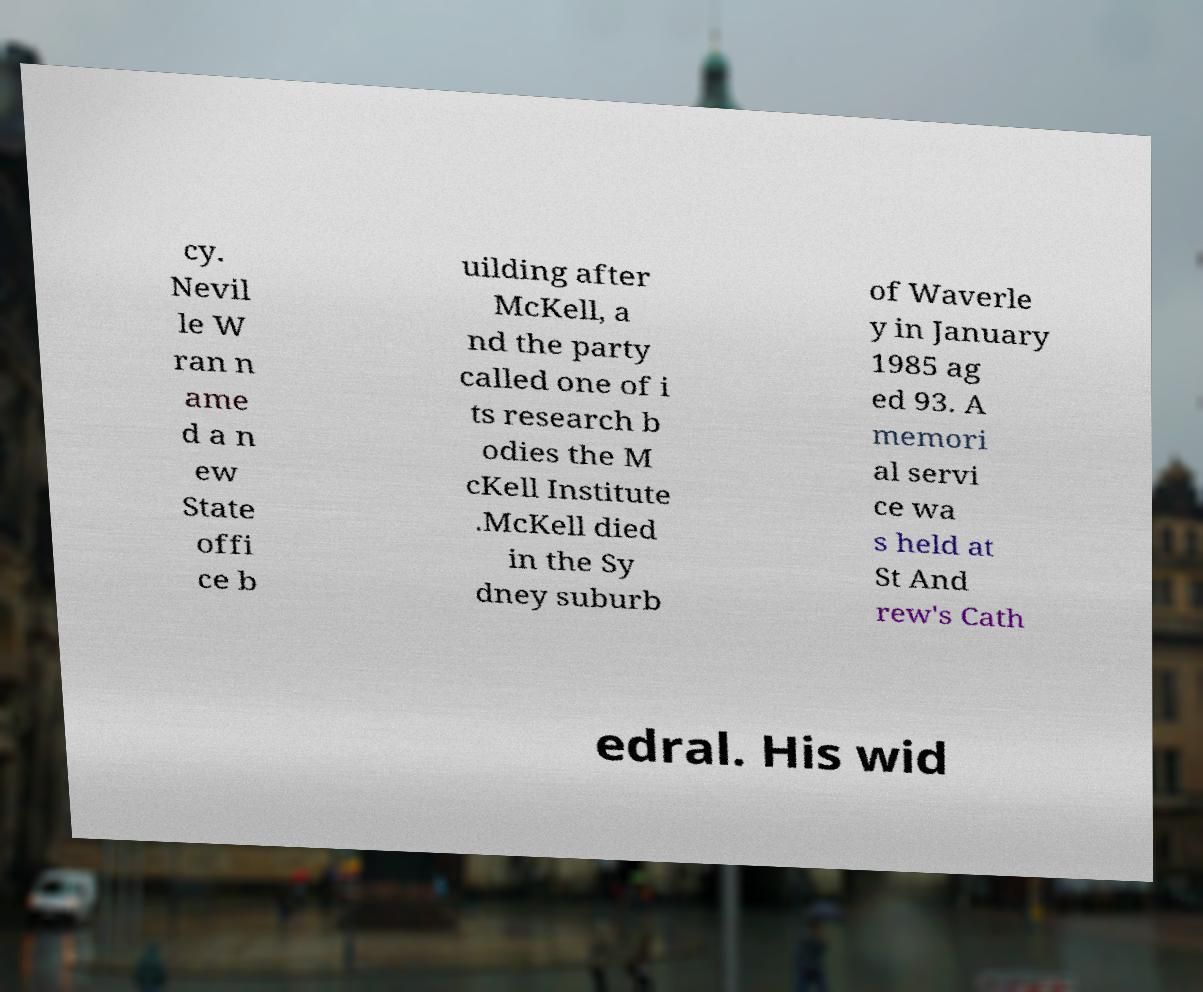Please identify and transcribe the text found in this image. cy. Nevil le W ran n ame d a n ew State offi ce b uilding after McKell, a nd the party called one of i ts research b odies the M cKell Institute .McKell died in the Sy dney suburb of Waverle y in January 1985 ag ed 93. A memori al servi ce wa s held at St And rew's Cath edral. His wid 